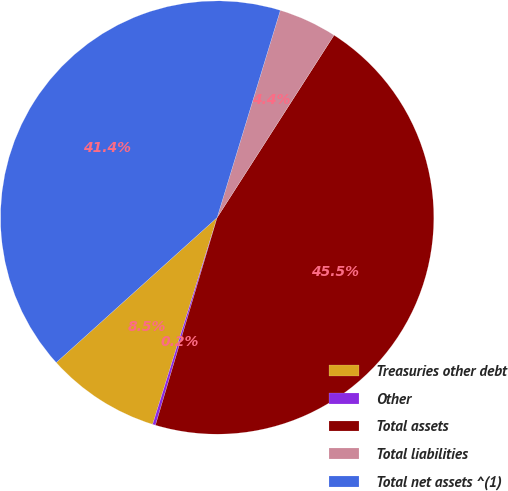Convert chart. <chart><loc_0><loc_0><loc_500><loc_500><pie_chart><fcel>Treasuries other debt<fcel>Other<fcel>Total assets<fcel>Total liabilities<fcel>Total net assets ^(1)<nl><fcel>8.51%<fcel>0.22%<fcel>45.52%<fcel>4.36%<fcel>41.38%<nl></chart> 